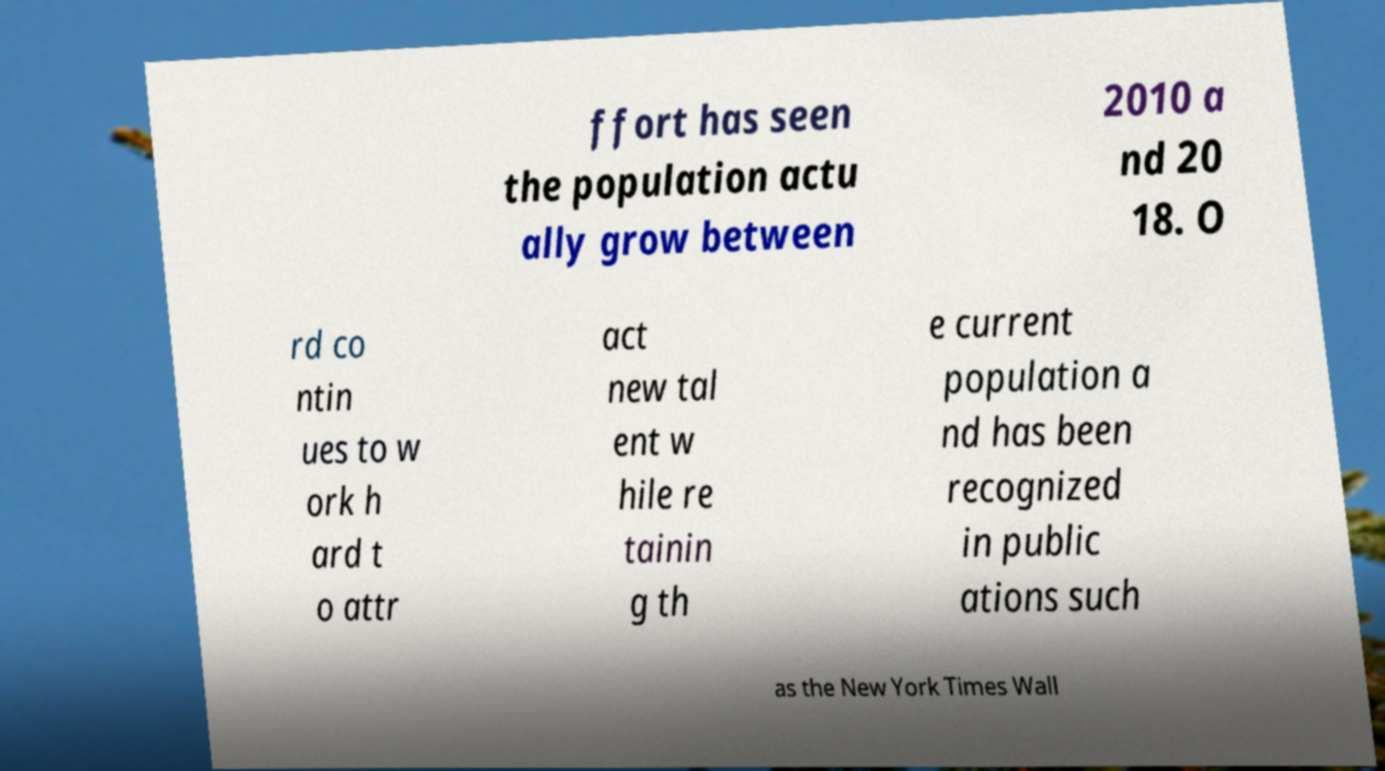For documentation purposes, I need the text within this image transcribed. Could you provide that? ffort has seen the population actu ally grow between 2010 a nd 20 18. O rd co ntin ues to w ork h ard t o attr act new tal ent w hile re tainin g th e current population a nd has been recognized in public ations such as the New York Times Wall 